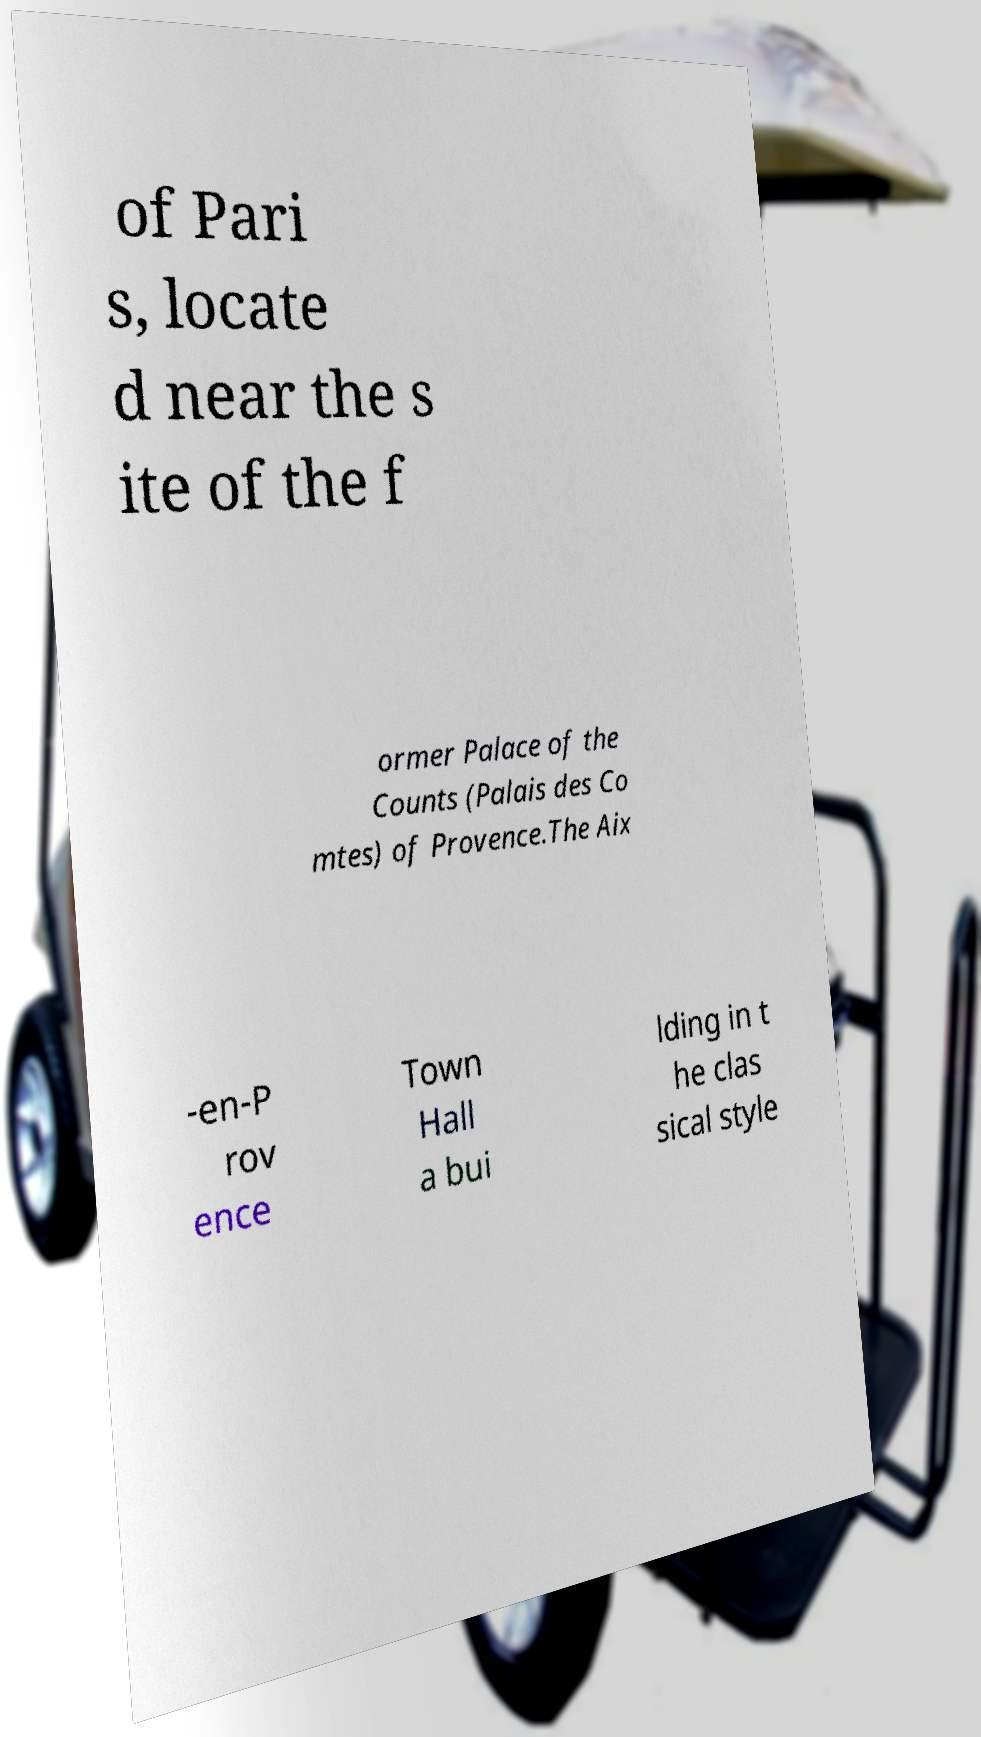For documentation purposes, I need the text within this image transcribed. Could you provide that? of Pari s, locate d near the s ite of the f ormer Palace of the Counts (Palais des Co mtes) of Provence.The Aix -en-P rov ence Town Hall a bui lding in t he clas sical style 